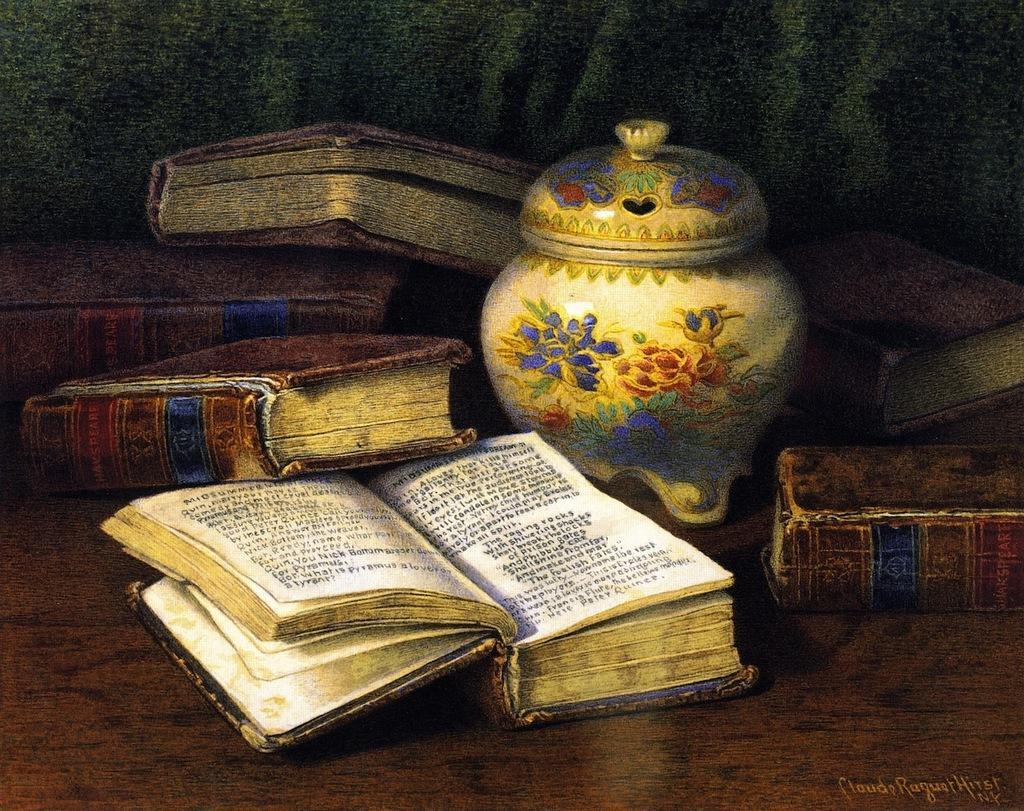In one or two sentences, can you explain what this image depicts? This is a picture of a painting where there are books , ceramic pot with a lid , and there is a signature. 